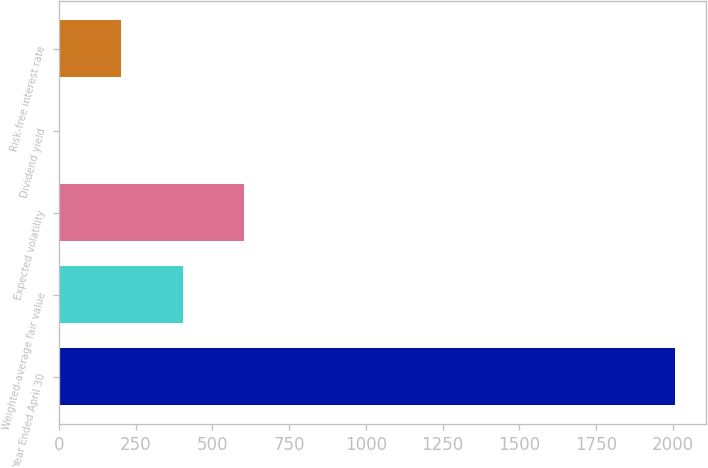Convert chart. <chart><loc_0><loc_0><loc_500><loc_500><bar_chart><fcel>Year Ended April 30<fcel>Weighted-average fair value<fcel>Expected volatility<fcel>Dividend yield<fcel>Risk-free interest rate<nl><fcel>2007<fcel>403.2<fcel>603.67<fcel>2.26<fcel>202.73<nl></chart> 